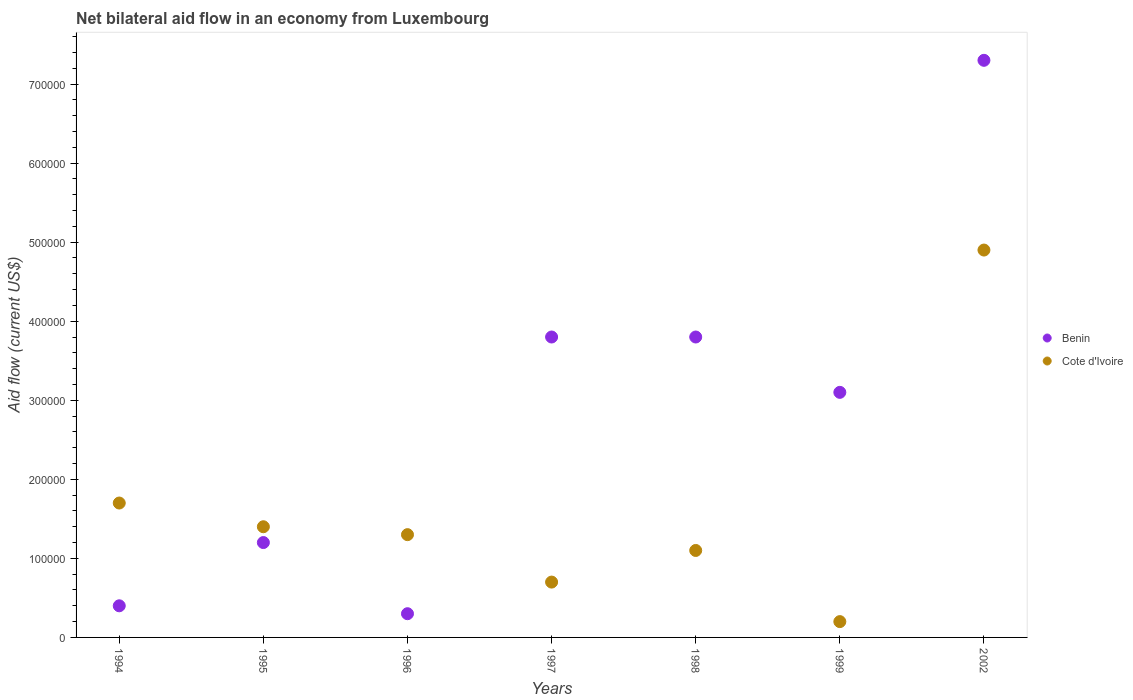What is the net bilateral aid flow in Cote d'Ivoire in 1999?
Keep it short and to the point. 2.00e+04. What is the total net bilateral aid flow in Benin in the graph?
Ensure brevity in your answer.  1.99e+06. What is the difference between the net bilateral aid flow in Cote d'Ivoire in 1995 and the net bilateral aid flow in Benin in 1997?
Your response must be concise. -2.40e+05. What is the average net bilateral aid flow in Benin per year?
Your answer should be very brief. 2.84e+05. In the year 1997, what is the difference between the net bilateral aid flow in Benin and net bilateral aid flow in Cote d'Ivoire?
Provide a succinct answer. 3.10e+05. What is the ratio of the net bilateral aid flow in Benin in 1998 to that in 2002?
Make the answer very short. 0.52. What is the difference between the highest and the second highest net bilateral aid flow in Benin?
Your answer should be very brief. 3.50e+05. What is the difference between the highest and the lowest net bilateral aid flow in Benin?
Keep it short and to the point. 7.00e+05. Does the net bilateral aid flow in Benin monotonically increase over the years?
Ensure brevity in your answer.  No. How many dotlines are there?
Ensure brevity in your answer.  2. Are the values on the major ticks of Y-axis written in scientific E-notation?
Offer a very short reply. No. Does the graph contain any zero values?
Offer a very short reply. No. Does the graph contain grids?
Provide a succinct answer. No. Where does the legend appear in the graph?
Your answer should be compact. Center right. What is the title of the graph?
Give a very brief answer. Net bilateral aid flow in an economy from Luxembourg. What is the Aid flow (current US$) in Benin in 1995?
Provide a short and direct response. 1.20e+05. What is the Aid flow (current US$) in Benin in 1996?
Provide a succinct answer. 3.00e+04. What is the Aid flow (current US$) of Cote d'Ivoire in 1996?
Your answer should be very brief. 1.30e+05. What is the Aid flow (current US$) of Cote d'Ivoire in 1997?
Ensure brevity in your answer.  7.00e+04. What is the Aid flow (current US$) in Benin in 1998?
Offer a terse response. 3.80e+05. What is the Aid flow (current US$) in Cote d'Ivoire in 1998?
Keep it short and to the point. 1.10e+05. What is the Aid flow (current US$) in Cote d'Ivoire in 1999?
Your answer should be compact. 2.00e+04. What is the Aid flow (current US$) in Benin in 2002?
Make the answer very short. 7.30e+05. Across all years, what is the maximum Aid flow (current US$) in Benin?
Provide a short and direct response. 7.30e+05. Across all years, what is the minimum Aid flow (current US$) in Benin?
Offer a very short reply. 3.00e+04. Across all years, what is the minimum Aid flow (current US$) of Cote d'Ivoire?
Provide a succinct answer. 2.00e+04. What is the total Aid flow (current US$) of Benin in the graph?
Offer a terse response. 1.99e+06. What is the total Aid flow (current US$) of Cote d'Ivoire in the graph?
Give a very brief answer. 1.13e+06. What is the difference between the Aid flow (current US$) of Benin in 1994 and that in 1995?
Provide a succinct answer. -8.00e+04. What is the difference between the Aid flow (current US$) of Cote d'Ivoire in 1994 and that in 1995?
Give a very brief answer. 3.00e+04. What is the difference between the Aid flow (current US$) of Benin in 1994 and that in 1997?
Offer a very short reply. -3.40e+05. What is the difference between the Aid flow (current US$) of Benin in 1994 and that in 1998?
Your answer should be very brief. -3.40e+05. What is the difference between the Aid flow (current US$) in Cote d'Ivoire in 1994 and that in 1998?
Provide a succinct answer. 6.00e+04. What is the difference between the Aid flow (current US$) in Benin in 1994 and that in 1999?
Make the answer very short. -2.70e+05. What is the difference between the Aid flow (current US$) in Cote d'Ivoire in 1994 and that in 1999?
Your answer should be compact. 1.50e+05. What is the difference between the Aid flow (current US$) of Benin in 1994 and that in 2002?
Offer a very short reply. -6.90e+05. What is the difference between the Aid flow (current US$) in Cote d'Ivoire in 1994 and that in 2002?
Your response must be concise. -3.20e+05. What is the difference between the Aid flow (current US$) of Cote d'Ivoire in 1995 and that in 1996?
Your answer should be very brief. 10000. What is the difference between the Aid flow (current US$) of Benin in 1995 and that in 1997?
Offer a very short reply. -2.60e+05. What is the difference between the Aid flow (current US$) in Cote d'Ivoire in 1995 and that in 1999?
Provide a succinct answer. 1.20e+05. What is the difference between the Aid flow (current US$) in Benin in 1995 and that in 2002?
Provide a short and direct response. -6.10e+05. What is the difference between the Aid flow (current US$) in Cote d'Ivoire in 1995 and that in 2002?
Provide a succinct answer. -3.50e+05. What is the difference between the Aid flow (current US$) in Benin in 1996 and that in 1997?
Your response must be concise. -3.50e+05. What is the difference between the Aid flow (current US$) of Cote d'Ivoire in 1996 and that in 1997?
Make the answer very short. 6.00e+04. What is the difference between the Aid flow (current US$) of Benin in 1996 and that in 1998?
Provide a succinct answer. -3.50e+05. What is the difference between the Aid flow (current US$) of Cote d'Ivoire in 1996 and that in 1998?
Your answer should be very brief. 2.00e+04. What is the difference between the Aid flow (current US$) in Benin in 1996 and that in 1999?
Your answer should be compact. -2.80e+05. What is the difference between the Aid flow (current US$) in Benin in 1996 and that in 2002?
Provide a short and direct response. -7.00e+05. What is the difference between the Aid flow (current US$) of Cote d'Ivoire in 1996 and that in 2002?
Your answer should be very brief. -3.60e+05. What is the difference between the Aid flow (current US$) in Benin in 1997 and that in 1998?
Make the answer very short. 0. What is the difference between the Aid flow (current US$) of Benin in 1997 and that in 1999?
Provide a short and direct response. 7.00e+04. What is the difference between the Aid flow (current US$) of Benin in 1997 and that in 2002?
Offer a very short reply. -3.50e+05. What is the difference between the Aid flow (current US$) of Cote d'Ivoire in 1997 and that in 2002?
Offer a very short reply. -4.20e+05. What is the difference between the Aid flow (current US$) in Benin in 1998 and that in 1999?
Offer a very short reply. 7.00e+04. What is the difference between the Aid flow (current US$) of Cote d'Ivoire in 1998 and that in 1999?
Offer a terse response. 9.00e+04. What is the difference between the Aid flow (current US$) in Benin in 1998 and that in 2002?
Make the answer very short. -3.50e+05. What is the difference between the Aid flow (current US$) in Cote d'Ivoire in 1998 and that in 2002?
Your response must be concise. -3.80e+05. What is the difference between the Aid flow (current US$) of Benin in 1999 and that in 2002?
Your answer should be very brief. -4.20e+05. What is the difference between the Aid flow (current US$) of Cote d'Ivoire in 1999 and that in 2002?
Your answer should be very brief. -4.70e+05. What is the difference between the Aid flow (current US$) in Benin in 1994 and the Aid flow (current US$) in Cote d'Ivoire in 1995?
Your answer should be very brief. -1.00e+05. What is the difference between the Aid flow (current US$) of Benin in 1994 and the Aid flow (current US$) of Cote d'Ivoire in 1996?
Provide a short and direct response. -9.00e+04. What is the difference between the Aid flow (current US$) in Benin in 1994 and the Aid flow (current US$) in Cote d'Ivoire in 1998?
Offer a terse response. -7.00e+04. What is the difference between the Aid flow (current US$) in Benin in 1994 and the Aid flow (current US$) in Cote d'Ivoire in 1999?
Your answer should be very brief. 2.00e+04. What is the difference between the Aid flow (current US$) in Benin in 1994 and the Aid flow (current US$) in Cote d'Ivoire in 2002?
Offer a terse response. -4.50e+05. What is the difference between the Aid flow (current US$) in Benin in 1995 and the Aid flow (current US$) in Cote d'Ivoire in 1996?
Provide a succinct answer. -10000. What is the difference between the Aid flow (current US$) of Benin in 1995 and the Aid flow (current US$) of Cote d'Ivoire in 1997?
Offer a very short reply. 5.00e+04. What is the difference between the Aid flow (current US$) of Benin in 1995 and the Aid flow (current US$) of Cote d'Ivoire in 1999?
Offer a terse response. 1.00e+05. What is the difference between the Aid flow (current US$) in Benin in 1995 and the Aid flow (current US$) in Cote d'Ivoire in 2002?
Give a very brief answer. -3.70e+05. What is the difference between the Aid flow (current US$) in Benin in 1996 and the Aid flow (current US$) in Cote d'Ivoire in 1997?
Keep it short and to the point. -4.00e+04. What is the difference between the Aid flow (current US$) in Benin in 1996 and the Aid flow (current US$) in Cote d'Ivoire in 1999?
Your response must be concise. 10000. What is the difference between the Aid flow (current US$) of Benin in 1996 and the Aid flow (current US$) of Cote d'Ivoire in 2002?
Give a very brief answer. -4.60e+05. What is the difference between the Aid flow (current US$) of Benin in 1997 and the Aid flow (current US$) of Cote d'Ivoire in 1998?
Give a very brief answer. 2.70e+05. What is the difference between the Aid flow (current US$) in Benin in 1997 and the Aid flow (current US$) in Cote d'Ivoire in 1999?
Ensure brevity in your answer.  3.60e+05. What is the difference between the Aid flow (current US$) in Benin in 1998 and the Aid flow (current US$) in Cote d'Ivoire in 1999?
Make the answer very short. 3.60e+05. What is the difference between the Aid flow (current US$) in Benin in 1998 and the Aid flow (current US$) in Cote d'Ivoire in 2002?
Offer a terse response. -1.10e+05. What is the average Aid flow (current US$) in Benin per year?
Offer a very short reply. 2.84e+05. What is the average Aid flow (current US$) of Cote d'Ivoire per year?
Make the answer very short. 1.61e+05. In the year 1995, what is the difference between the Aid flow (current US$) of Benin and Aid flow (current US$) of Cote d'Ivoire?
Your answer should be very brief. -2.00e+04. In the year 1996, what is the difference between the Aid flow (current US$) in Benin and Aid flow (current US$) in Cote d'Ivoire?
Your answer should be very brief. -1.00e+05. In the year 1997, what is the difference between the Aid flow (current US$) of Benin and Aid flow (current US$) of Cote d'Ivoire?
Your answer should be very brief. 3.10e+05. In the year 1998, what is the difference between the Aid flow (current US$) of Benin and Aid flow (current US$) of Cote d'Ivoire?
Your answer should be very brief. 2.70e+05. In the year 2002, what is the difference between the Aid flow (current US$) of Benin and Aid flow (current US$) of Cote d'Ivoire?
Your answer should be compact. 2.40e+05. What is the ratio of the Aid flow (current US$) of Cote d'Ivoire in 1994 to that in 1995?
Make the answer very short. 1.21. What is the ratio of the Aid flow (current US$) of Benin in 1994 to that in 1996?
Your answer should be compact. 1.33. What is the ratio of the Aid flow (current US$) of Cote d'Ivoire in 1994 to that in 1996?
Offer a very short reply. 1.31. What is the ratio of the Aid flow (current US$) in Benin in 1994 to that in 1997?
Provide a short and direct response. 0.11. What is the ratio of the Aid flow (current US$) in Cote d'Ivoire in 1994 to that in 1997?
Your answer should be compact. 2.43. What is the ratio of the Aid flow (current US$) of Benin in 1994 to that in 1998?
Your answer should be very brief. 0.11. What is the ratio of the Aid flow (current US$) in Cote d'Ivoire in 1994 to that in 1998?
Your answer should be very brief. 1.55. What is the ratio of the Aid flow (current US$) in Benin in 1994 to that in 1999?
Provide a short and direct response. 0.13. What is the ratio of the Aid flow (current US$) of Benin in 1994 to that in 2002?
Provide a succinct answer. 0.05. What is the ratio of the Aid flow (current US$) in Cote d'Ivoire in 1994 to that in 2002?
Offer a terse response. 0.35. What is the ratio of the Aid flow (current US$) of Benin in 1995 to that in 1997?
Give a very brief answer. 0.32. What is the ratio of the Aid flow (current US$) of Cote d'Ivoire in 1995 to that in 1997?
Your answer should be very brief. 2. What is the ratio of the Aid flow (current US$) of Benin in 1995 to that in 1998?
Give a very brief answer. 0.32. What is the ratio of the Aid flow (current US$) in Cote d'Ivoire in 1995 to that in 1998?
Give a very brief answer. 1.27. What is the ratio of the Aid flow (current US$) in Benin in 1995 to that in 1999?
Ensure brevity in your answer.  0.39. What is the ratio of the Aid flow (current US$) of Benin in 1995 to that in 2002?
Offer a terse response. 0.16. What is the ratio of the Aid flow (current US$) in Cote d'Ivoire in 1995 to that in 2002?
Give a very brief answer. 0.29. What is the ratio of the Aid flow (current US$) of Benin in 1996 to that in 1997?
Your answer should be compact. 0.08. What is the ratio of the Aid flow (current US$) in Cote d'Ivoire in 1996 to that in 1997?
Your response must be concise. 1.86. What is the ratio of the Aid flow (current US$) of Benin in 1996 to that in 1998?
Your answer should be compact. 0.08. What is the ratio of the Aid flow (current US$) in Cote d'Ivoire in 1996 to that in 1998?
Your response must be concise. 1.18. What is the ratio of the Aid flow (current US$) of Benin in 1996 to that in 1999?
Keep it short and to the point. 0.1. What is the ratio of the Aid flow (current US$) in Benin in 1996 to that in 2002?
Your answer should be very brief. 0.04. What is the ratio of the Aid flow (current US$) of Cote d'Ivoire in 1996 to that in 2002?
Your answer should be very brief. 0.27. What is the ratio of the Aid flow (current US$) in Cote d'Ivoire in 1997 to that in 1998?
Your response must be concise. 0.64. What is the ratio of the Aid flow (current US$) of Benin in 1997 to that in 1999?
Provide a succinct answer. 1.23. What is the ratio of the Aid flow (current US$) in Cote d'Ivoire in 1997 to that in 1999?
Your answer should be very brief. 3.5. What is the ratio of the Aid flow (current US$) in Benin in 1997 to that in 2002?
Your answer should be compact. 0.52. What is the ratio of the Aid flow (current US$) of Cote d'Ivoire in 1997 to that in 2002?
Make the answer very short. 0.14. What is the ratio of the Aid flow (current US$) in Benin in 1998 to that in 1999?
Your response must be concise. 1.23. What is the ratio of the Aid flow (current US$) of Benin in 1998 to that in 2002?
Your response must be concise. 0.52. What is the ratio of the Aid flow (current US$) of Cote d'Ivoire in 1998 to that in 2002?
Offer a terse response. 0.22. What is the ratio of the Aid flow (current US$) of Benin in 1999 to that in 2002?
Your response must be concise. 0.42. What is the ratio of the Aid flow (current US$) in Cote d'Ivoire in 1999 to that in 2002?
Provide a short and direct response. 0.04. What is the difference between the highest and the second highest Aid flow (current US$) of Benin?
Offer a very short reply. 3.50e+05. What is the difference between the highest and the second highest Aid flow (current US$) in Cote d'Ivoire?
Make the answer very short. 3.20e+05. What is the difference between the highest and the lowest Aid flow (current US$) in Benin?
Provide a short and direct response. 7.00e+05. 